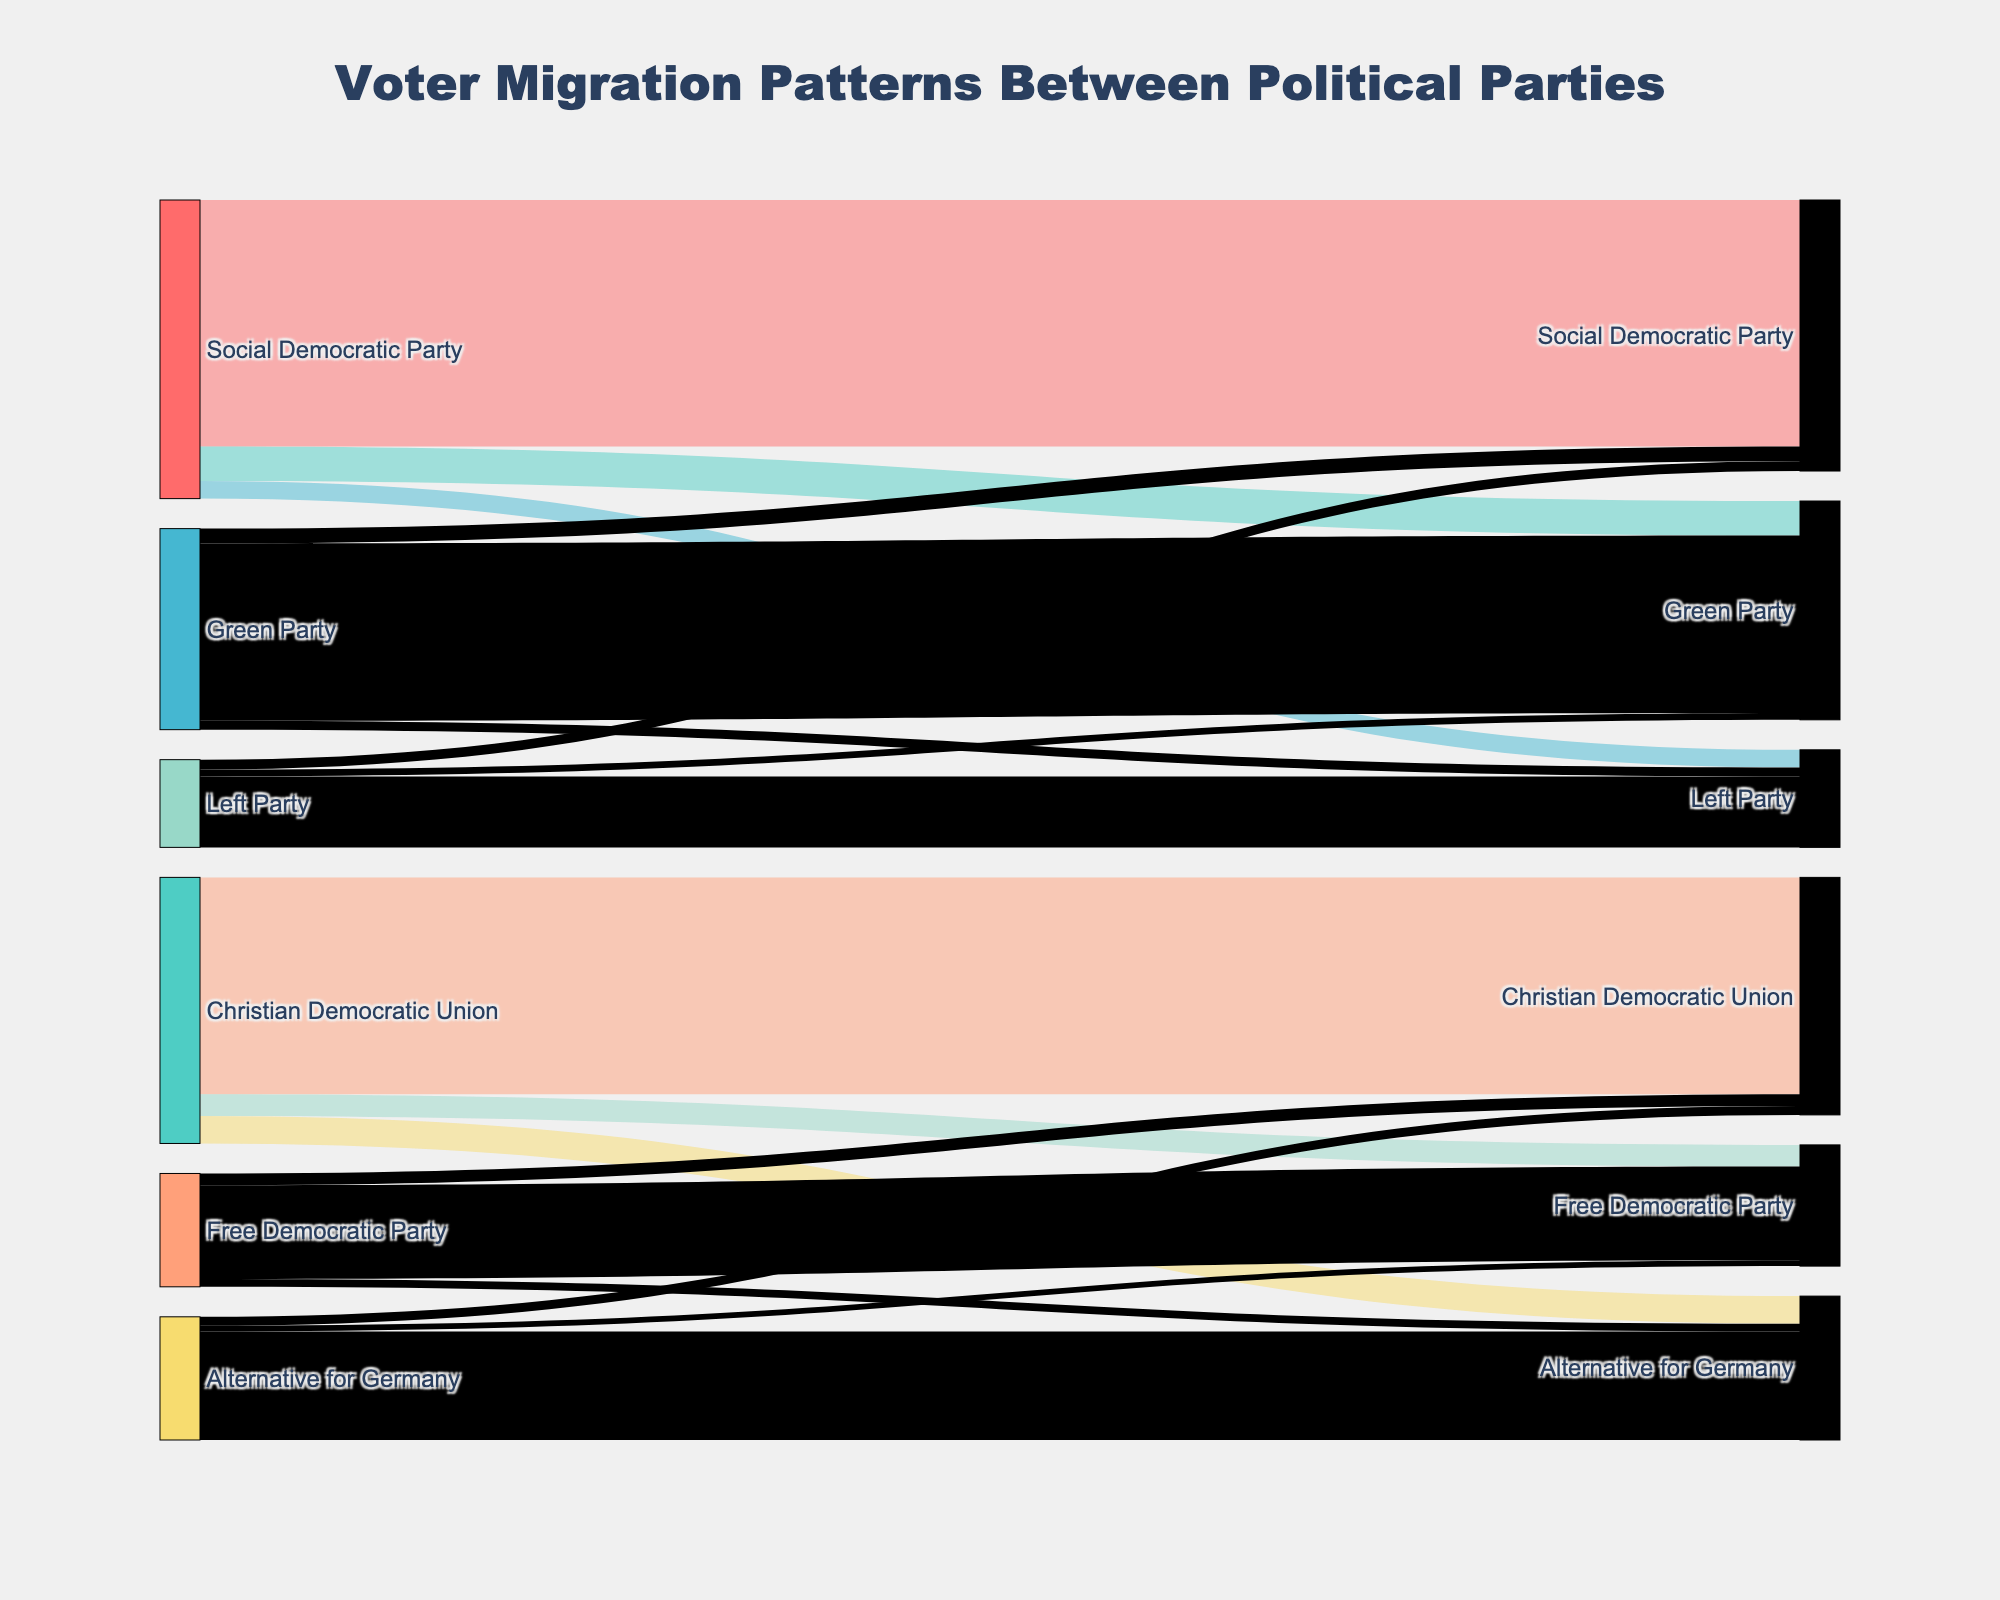Which party lost the most voters to the Green Party in the most recent election? The diagram shows several streams from different parties to the Green Party. The widths of the streams represent the number of voters. The stream from the Social Democratic Party to the Green Party is the widest, indicating the largest number of voters, which is 350,000.
Answer: Social Democratic Party How many voters did the Free Democratic Party retain? In the Sankey Diagram, the width of the stream going from the Free Democratic Party to itself represents the number of voters retained. According to the data, this number is 950,000.
Answer: 950,000 Which party gained the least voters from voter migration? To find this, we look at all the incoming streams to each party. The couple of smallest values seen in the diagram are 60,000 (from Alternative for Germany to Free Democratic Party) and 70,000 (Green Party from Left Party). Out of these, the lowest value is to the Free Democratic Party from Alternative for Germany.
Answer: Free Democratic Party from Alternative for Germany What is the total number of voters that shifted away from the Christian Democratic Union? To determine this, add up all the outgoing streams from the Christian Democratic Union which are 220,000 (to Free Democratic Party) and 280,000 (to Alternative for Germany). The sum is 220,000 + 280,000 = 500,000.
Answer: 500,000 Which party received the highest number of incoming voters from other parties (excluding itself)? To find the party that gained the most voters from others, look at the total incoming stream widths for each party. The largest inflows come to the Green Party and the count is 350,000 (Social Democratic Party) + 70,000 (Left Party) = 420,000.
Answer: Green Party How many voters moved from the Alternative for Germany to the Christian Democratic Union? The stream from the Alternative for Germany to the Christian Democratic Union represents the number of voters that moved, and it is depicted with a value of 90,000.
Answer: 90,000 Which party retained the most voters? The streams that represent voter retention (when source and target are the same) can be compared. The Social Democratic Party retained 2,500,000 voters which is the highest among all.
Answer: Social Democratic Party 